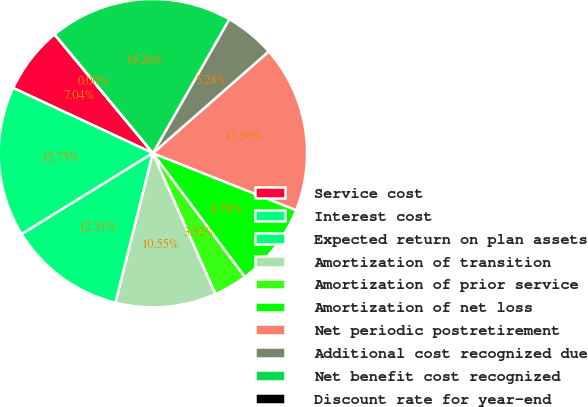Convert chart. <chart><loc_0><loc_0><loc_500><loc_500><pie_chart><fcel>Service cost<fcel>Interest cost<fcel>Expected return on plan assets<fcel>Amortization of transition<fcel>Amortization of prior service<fcel>Amortization of net loss<fcel>Net periodic postretirement<fcel>Additional cost recognized due<fcel>Net benefit cost recognized<fcel>Discount rate for year-end<nl><fcel>7.04%<fcel>15.75%<fcel>12.31%<fcel>10.55%<fcel>3.52%<fcel>8.79%<fcel>17.5%<fcel>5.28%<fcel>19.26%<fcel>0.0%<nl></chart> 